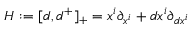<formula> <loc_0><loc_0><loc_500><loc_500>H \colon = [ d , d ^ { + } ] _ { + } = x ^ { i } \partial _ { x ^ { i } } + d x ^ { i } \partial _ { d x ^ { i } }</formula> 